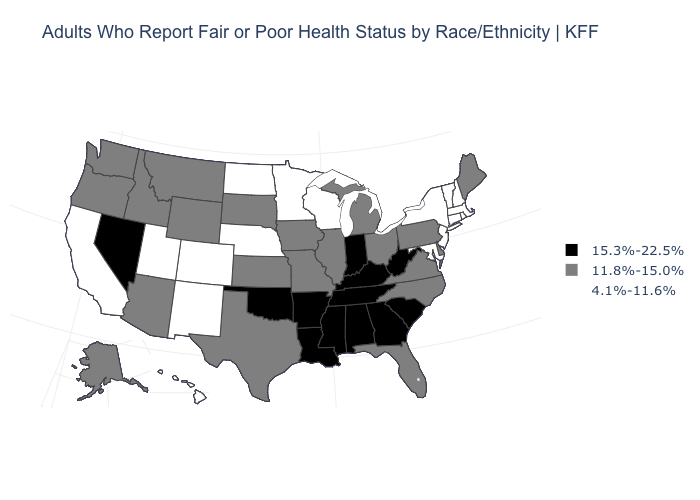What is the value of Pennsylvania?
Be succinct. 11.8%-15.0%. What is the value of Wyoming?
Quick response, please. 11.8%-15.0%. Name the states that have a value in the range 11.8%-15.0%?
Give a very brief answer. Alaska, Arizona, Delaware, Florida, Idaho, Illinois, Iowa, Kansas, Maine, Michigan, Missouri, Montana, North Carolina, Ohio, Oregon, Pennsylvania, South Dakota, Texas, Virginia, Washington, Wyoming. Does Tennessee have the same value as Colorado?
Concise answer only. No. What is the value of Montana?
Write a very short answer. 11.8%-15.0%. How many symbols are there in the legend?
Keep it brief. 3. What is the lowest value in the USA?
Write a very short answer. 4.1%-11.6%. Does South Carolina have the lowest value in the South?
Answer briefly. No. What is the lowest value in the MidWest?
Write a very short answer. 4.1%-11.6%. What is the highest value in the USA?
Answer briefly. 15.3%-22.5%. Name the states that have a value in the range 15.3%-22.5%?
Keep it brief. Alabama, Arkansas, Georgia, Indiana, Kentucky, Louisiana, Mississippi, Nevada, Oklahoma, South Carolina, Tennessee, West Virginia. Does Colorado have the lowest value in the USA?
Quick response, please. Yes. Name the states that have a value in the range 15.3%-22.5%?
Concise answer only. Alabama, Arkansas, Georgia, Indiana, Kentucky, Louisiana, Mississippi, Nevada, Oklahoma, South Carolina, Tennessee, West Virginia. What is the value of Arkansas?
Be succinct. 15.3%-22.5%. 